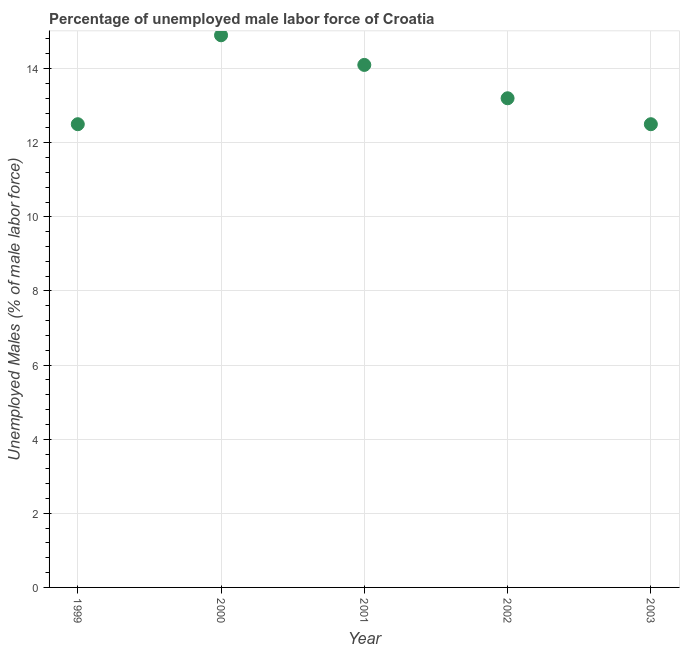What is the total unemployed male labour force in 2003?
Provide a succinct answer. 12.5. Across all years, what is the maximum total unemployed male labour force?
Your answer should be compact. 14.9. Across all years, what is the minimum total unemployed male labour force?
Your answer should be very brief. 12.5. In which year was the total unemployed male labour force maximum?
Provide a succinct answer. 2000. In which year was the total unemployed male labour force minimum?
Ensure brevity in your answer.  1999. What is the sum of the total unemployed male labour force?
Offer a terse response. 67.2. What is the difference between the total unemployed male labour force in 2000 and 2003?
Offer a terse response. 2.4. What is the average total unemployed male labour force per year?
Provide a short and direct response. 13.44. What is the median total unemployed male labour force?
Provide a short and direct response. 13.2. What is the ratio of the total unemployed male labour force in 2000 to that in 2003?
Your response must be concise. 1.19. Is the total unemployed male labour force in 2002 less than that in 2003?
Give a very brief answer. No. What is the difference between the highest and the second highest total unemployed male labour force?
Make the answer very short. 0.8. What is the difference between the highest and the lowest total unemployed male labour force?
Give a very brief answer. 2.4. Does the total unemployed male labour force monotonically increase over the years?
Offer a very short reply. No. How many years are there in the graph?
Ensure brevity in your answer.  5. What is the difference between two consecutive major ticks on the Y-axis?
Make the answer very short. 2. Does the graph contain grids?
Make the answer very short. Yes. What is the title of the graph?
Your response must be concise. Percentage of unemployed male labor force of Croatia. What is the label or title of the Y-axis?
Keep it short and to the point. Unemployed Males (% of male labor force). What is the Unemployed Males (% of male labor force) in 2000?
Your answer should be very brief. 14.9. What is the Unemployed Males (% of male labor force) in 2001?
Provide a succinct answer. 14.1. What is the Unemployed Males (% of male labor force) in 2002?
Your answer should be compact. 13.2. What is the difference between the Unemployed Males (% of male labor force) in 1999 and 2001?
Provide a short and direct response. -1.6. What is the difference between the Unemployed Males (% of male labor force) in 1999 and 2002?
Your answer should be very brief. -0.7. What is the difference between the Unemployed Males (% of male labor force) in 2000 and 2002?
Your answer should be very brief. 1.7. What is the difference between the Unemployed Males (% of male labor force) in 2001 and 2002?
Keep it short and to the point. 0.9. What is the difference between the Unemployed Males (% of male labor force) in 2001 and 2003?
Ensure brevity in your answer.  1.6. What is the ratio of the Unemployed Males (% of male labor force) in 1999 to that in 2000?
Your answer should be very brief. 0.84. What is the ratio of the Unemployed Males (% of male labor force) in 1999 to that in 2001?
Keep it short and to the point. 0.89. What is the ratio of the Unemployed Males (% of male labor force) in 1999 to that in 2002?
Provide a short and direct response. 0.95. What is the ratio of the Unemployed Males (% of male labor force) in 2000 to that in 2001?
Offer a terse response. 1.06. What is the ratio of the Unemployed Males (% of male labor force) in 2000 to that in 2002?
Give a very brief answer. 1.13. What is the ratio of the Unemployed Males (% of male labor force) in 2000 to that in 2003?
Offer a terse response. 1.19. What is the ratio of the Unemployed Males (% of male labor force) in 2001 to that in 2002?
Make the answer very short. 1.07. What is the ratio of the Unemployed Males (% of male labor force) in 2001 to that in 2003?
Provide a short and direct response. 1.13. What is the ratio of the Unemployed Males (% of male labor force) in 2002 to that in 2003?
Give a very brief answer. 1.06. 